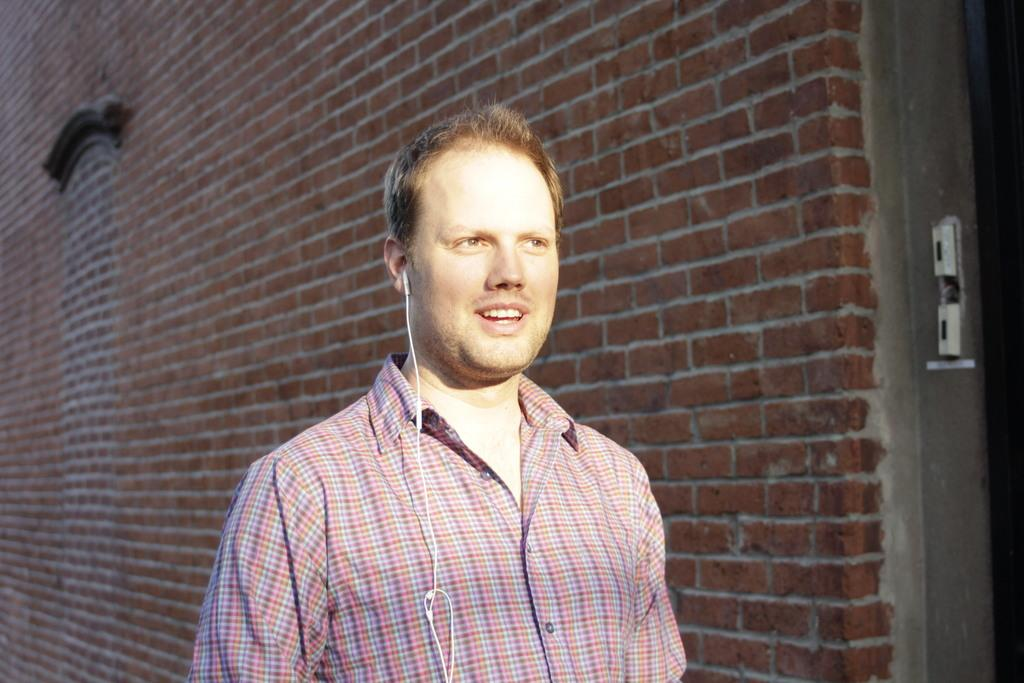What type of structure is visible in the image? There is a building in the image. What type of accessory is present in the image? There are earphones in the image. Can you describe the person in the image? There is a person standing in the image. What type of competition is taking place in the image? There is no competition present in the image. What time of day is depicted in the image? The provided facts do not give any information about the time of day, so it cannot be determined from the image. 